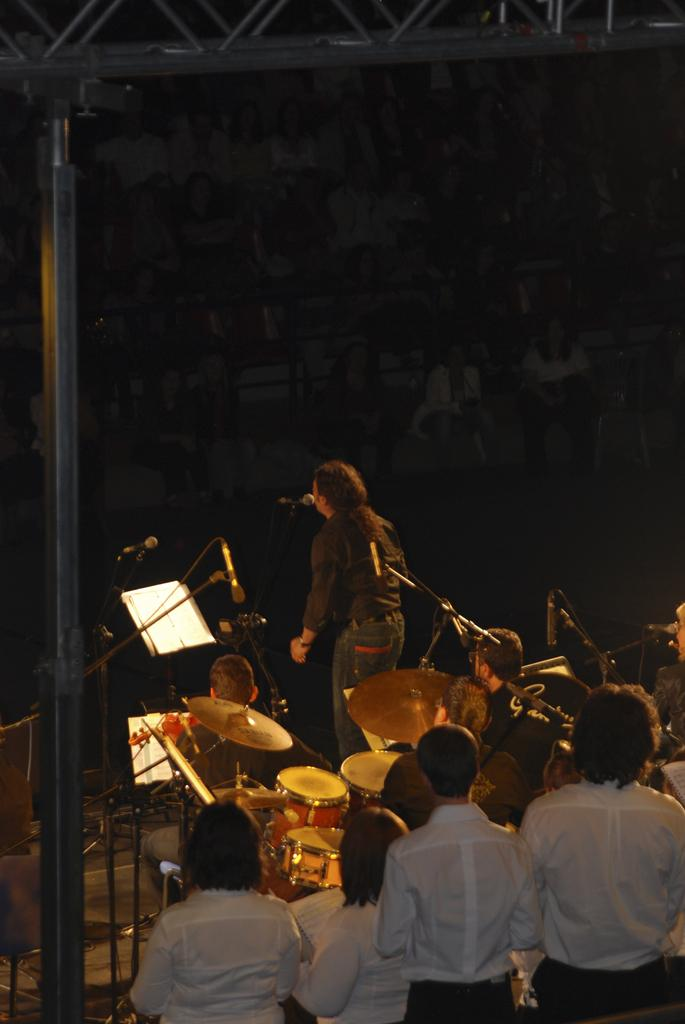What is the man in the image doing? The man in the image is standing and singing. What is the man holding in the image? There is a microphone in the image. How many people are sitting in the image? There are two men sitting on chairs in the image. What is the general arrangement of people in the image? There is a group of people standing in the image. What type of food is the man cooking on the sofa in the image? There is no man cooking on a sofa in the image; the man is singing with a microphone. 